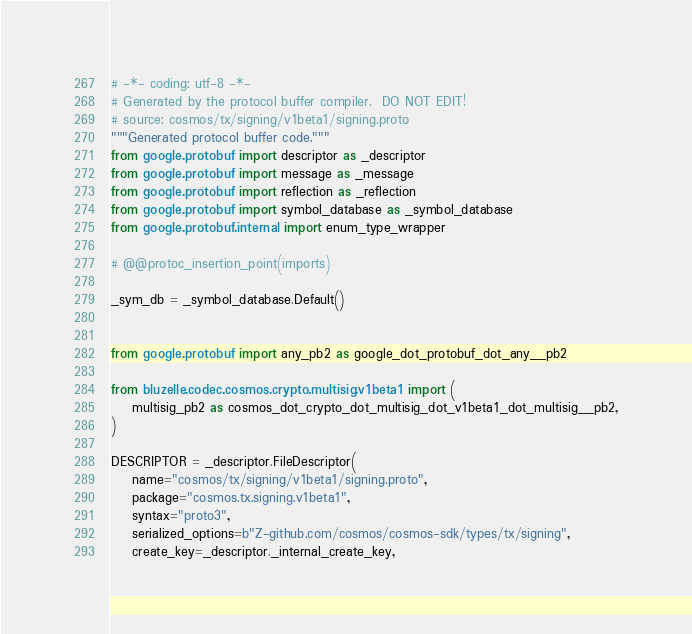Convert code to text. <code><loc_0><loc_0><loc_500><loc_500><_Python_># -*- coding: utf-8 -*-
# Generated by the protocol buffer compiler.  DO NOT EDIT!
# source: cosmos/tx/signing/v1beta1/signing.proto
"""Generated protocol buffer code."""
from google.protobuf import descriptor as _descriptor
from google.protobuf import message as _message
from google.protobuf import reflection as _reflection
from google.protobuf import symbol_database as _symbol_database
from google.protobuf.internal import enum_type_wrapper

# @@protoc_insertion_point(imports)

_sym_db = _symbol_database.Default()


from google.protobuf import any_pb2 as google_dot_protobuf_dot_any__pb2

from bluzelle.codec.cosmos.crypto.multisig.v1beta1 import (
    multisig_pb2 as cosmos_dot_crypto_dot_multisig_dot_v1beta1_dot_multisig__pb2,
)

DESCRIPTOR = _descriptor.FileDescriptor(
    name="cosmos/tx/signing/v1beta1/signing.proto",
    package="cosmos.tx.signing.v1beta1",
    syntax="proto3",
    serialized_options=b"Z-github.com/cosmos/cosmos-sdk/types/tx/signing",
    create_key=_descriptor._internal_create_key,</code> 